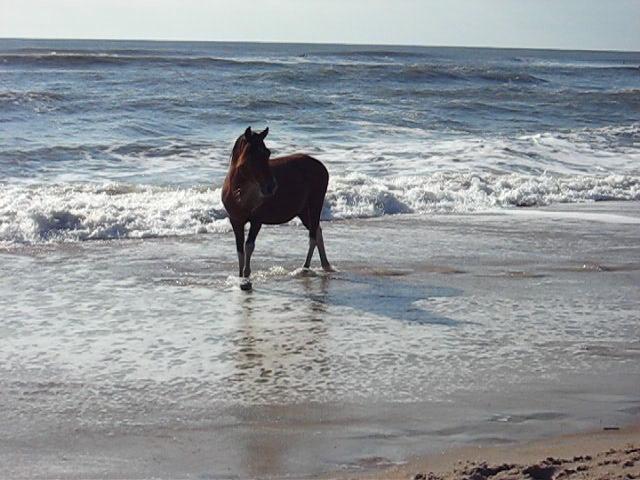What animal is in the water?
Give a very brief answer. Horse. Are there any rocks in the sea?
Give a very brief answer. No. Did someone apply a filter to that photo?
Quick response, please. No. How does the horse know where to go?
Give a very brief answer. Instinct. How many animals are standing in the water?
Write a very short answer. 1. Is the horse standing on a beach?
Give a very brief answer. Yes. Where is the horse located?
Be succinct. Beach. Is that a goat?
Keep it brief. No. 